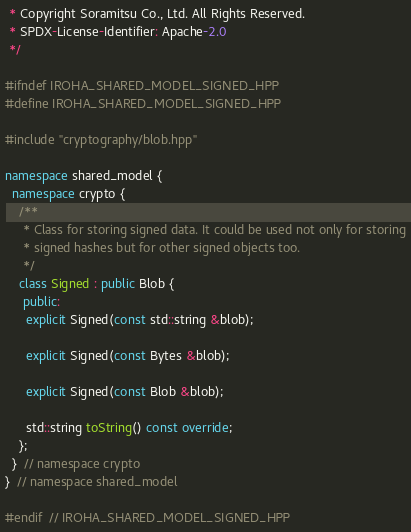<code> <loc_0><loc_0><loc_500><loc_500><_C++_> * Copyright Soramitsu Co., Ltd. All Rights Reserved.
 * SPDX-License-Identifier: Apache-2.0
 */

#ifndef IROHA_SHARED_MODEL_SIGNED_HPP
#define IROHA_SHARED_MODEL_SIGNED_HPP

#include "cryptography/blob.hpp"

namespace shared_model {
  namespace crypto {
    /**
     * Class for storing signed data. It could be used not only for storing
     * signed hashes but for other signed objects too.
     */
    class Signed : public Blob {
     public:
      explicit Signed(const std::string &blob);

      explicit Signed(const Bytes &blob);

      explicit Signed(const Blob &blob);

      std::string toString() const override;
    };
  }  // namespace crypto
}  // namespace shared_model

#endif  // IROHA_SHARED_MODEL_SIGNED_HPP
</code> 